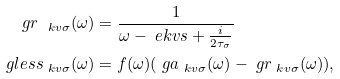Convert formula to latex. <formula><loc_0><loc_0><loc_500><loc_500>\ g r _ { \ k v \sigma } ( \omega ) & = \frac { 1 } { \omega - \ e k v s + \frac { i } { 2 \tau _ { \sigma } } } \\ \ g l e s s _ { \ k v \sigma } ( \omega ) & = f ( \omega ) ( \ g a _ { \ k v \sigma } ( \omega ) - \ g r _ { \ k v \sigma } ( \omega ) ) ,</formula> 